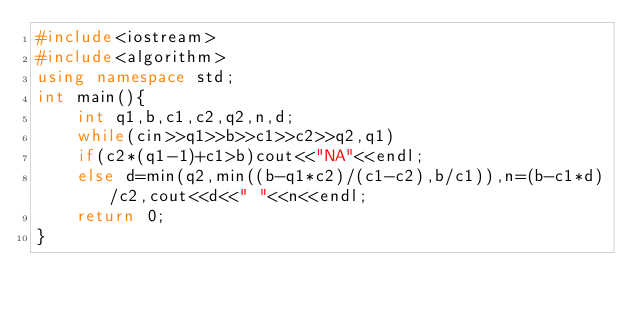<code> <loc_0><loc_0><loc_500><loc_500><_C++_>#include<iostream>
#include<algorithm>
using namespace std;
int main(){
	int q1,b,c1,c2,q2,n,d;
	while(cin>>q1>>b>>c1>>c2>>q2,q1)
	if(c2*(q1-1)+c1>b)cout<<"NA"<<endl;
	else d=min(q2,min((b-q1*c2)/(c1-c2),b/c1)),n=(b-c1*d)/c2,cout<<d<<" "<<n<<endl;
	return 0;
}</code> 